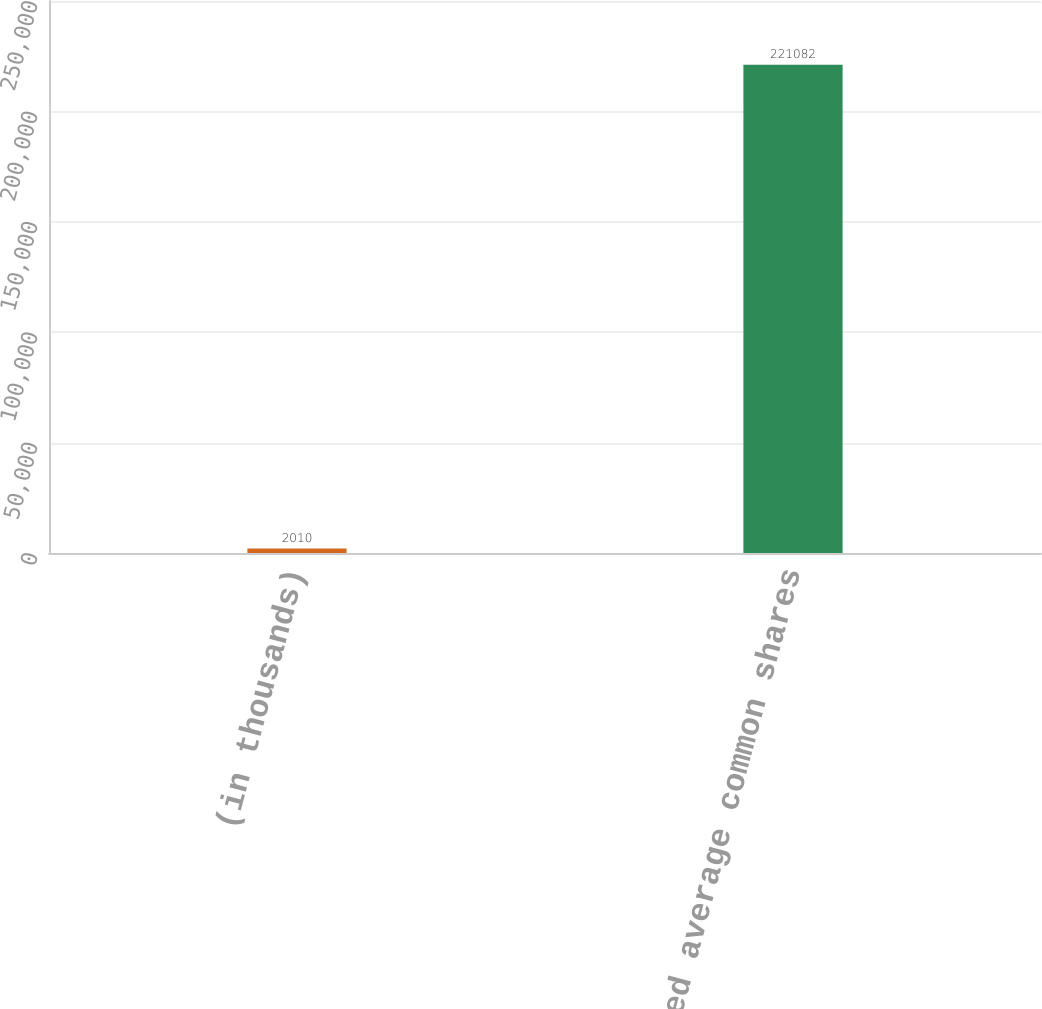Convert chart to OTSL. <chart><loc_0><loc_0><loc_500><loc_500><bar_chart><fcel>(in thousands)<fcel>Weighted average common shares<nl><fcel>2010<fcel>221082<nl></chart> 